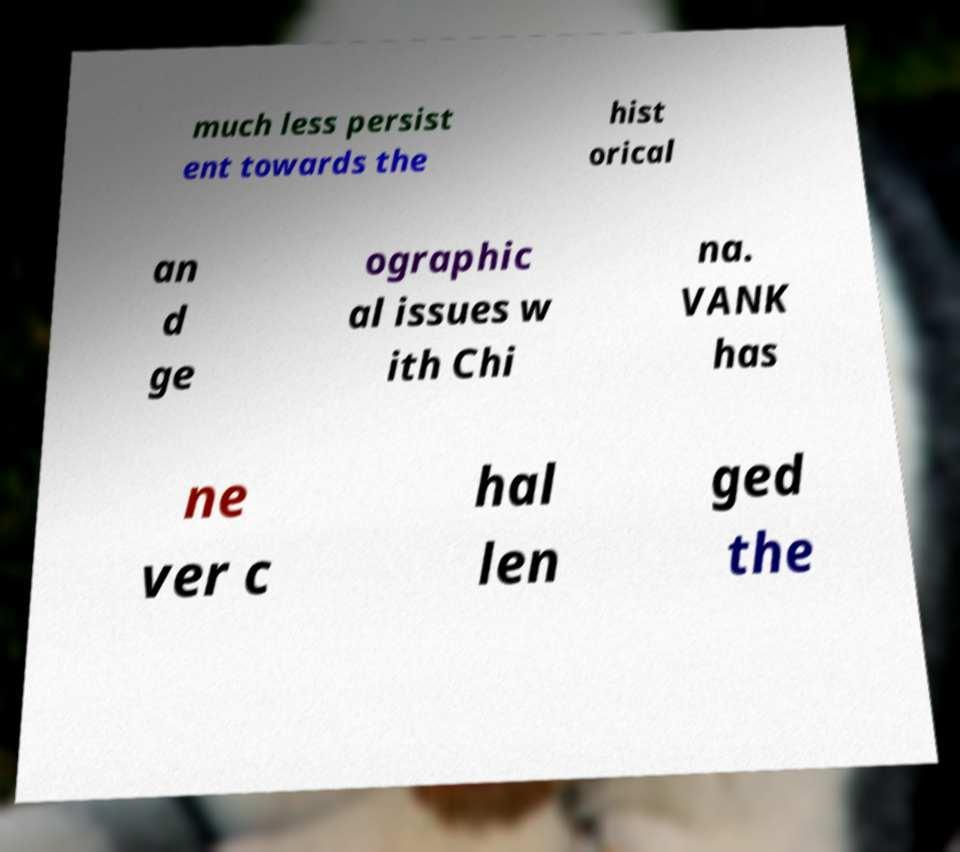What messages or text are displayed in this image? I need them in a readable, typed format. much less persist ent towards the hist orical an d ge ographic al issues w ith Chi na. VANK has ne ver c hal len ged the 